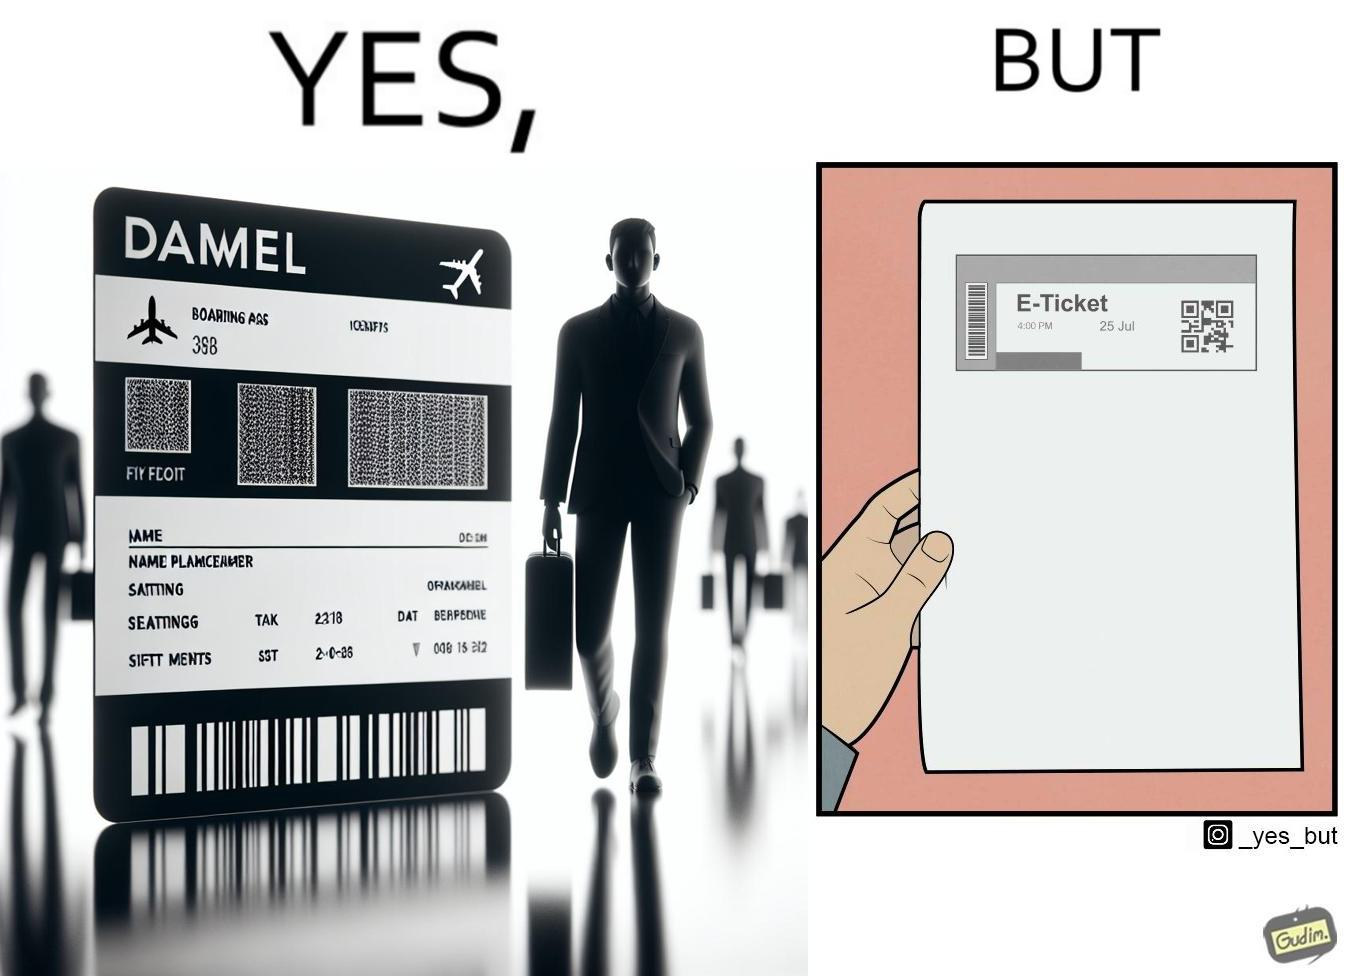Provide a description of this image. The images are ironic since even though e-tickets are provided to save resources like paper, people choose to print out e-tickets on large sheets of paper which leads to more wastage 